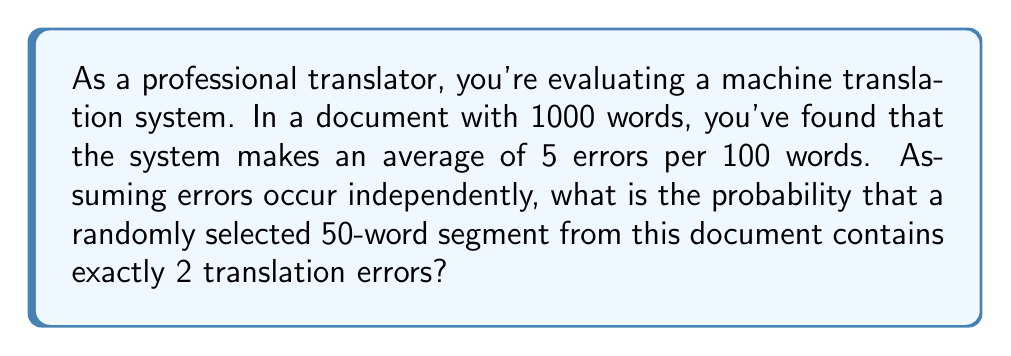Can you solve this math problem? To solve this problem, we'll use the Binomial probability distribution, as we're dealing with a fixed number of independent trials (words) with a constant probability of success (error) for each trial.

Step 1: Calculate the probability of an error for a single word.
$p = \frac{5 \text{ errors}}{100 \text{ words}} = 0.05$

Step 2: Determine the probability of no error for a single word.
$q = 1 - p = 1 - 0.05 = 0.95$

Step 3: Set up the Binomial probability formula.
$$P(X = k) = \binom{n}{k} p^k q^{n-k}$$
Where:
$n = 50$ (number of words in the segment)
$k = 2$ (number of errors we're looking for)
$p = 0.05$ (probability of an error)
$q = 0.95$ (probability of no error)

Step 4: Calculate the binomial coefficient.
$$\binom{50}{2} = \frac{50!}{2!(50-2)!} = 1225$$

Step 5: Plug all values into the formula.
$$P(X = 2) = 1225 \cdot (0.05)^2 \cdot (0.95)^{48}$$

Step 6: Calculate the final probability.
$$P(X = 2) = 1225 \cdot 0.0025 \cdot 0.0872 = 0.2670$$

Therefore, the probability of exactly 2 errors in a 50-word segment is approximately 0.2670 or 26.70%.
Answer: 0.2670 